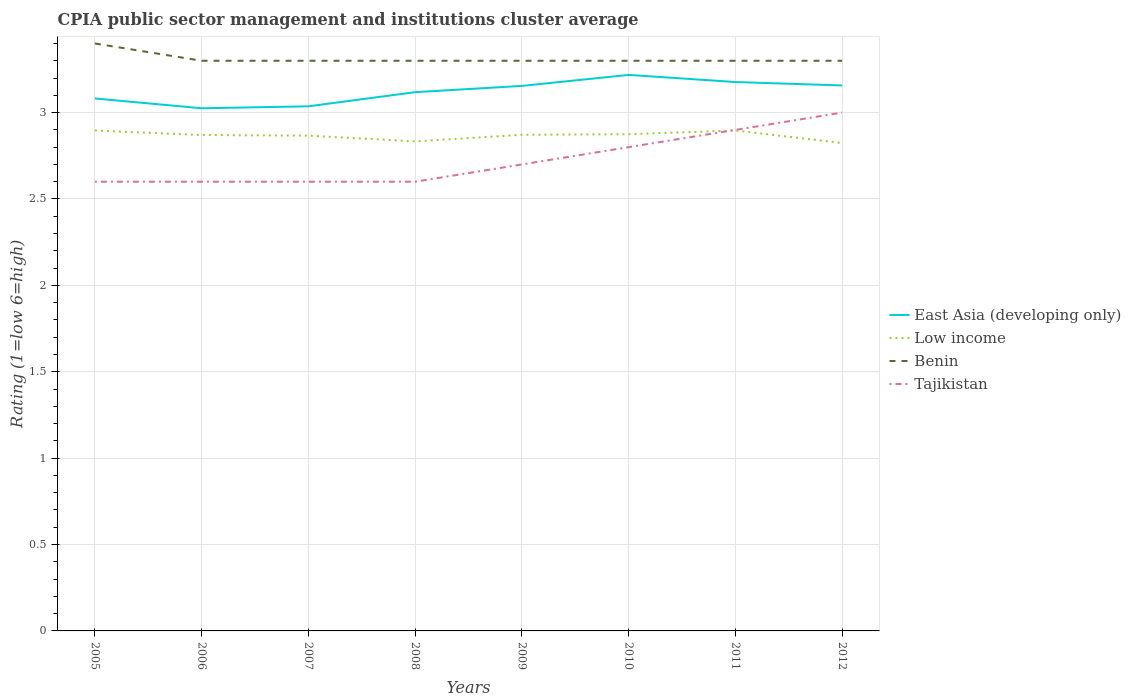Does the line corresponding to Low income intersect with the line corresponding to Benin?
Ensure brevity in your answer.  No. Is the number of lines equal to the number of legend labels?
Your answer should be compact. Yes. Across all years, what is the maximum CPIA rating in East Asia (developing only)?
Offer a very short reply. 3.02. What is the total CPIA rating in Low income in the graph?
Offer a very short reply. 0.06. What is the difference between the highest and the second highest CPIA rating in Tajikistan?
Your response must be concise. 0.4. What is the difference between the highest and the lowest CPIA rating in Benin?
Your answer should be compact. 1. Is the CPIA rating in Low income strictly greater than the CPIA rating in Benin over the years?
Ensure brevity in your answer.  Yes. What is the difference between two consecutive major ticks on the Y-axis?
Your response must be concise. 0.5. Are the values on the major ticks of Y-axis written in scientific E-notation?
Provide a short and direct response. No. Where does the legend appear in the graph?
Your answer should be compact. Center right. How many legend labels are there?
Your response must be concise. 4. What is the title of the graph?
Make the answer very short. CPIA public sector management and institutions cluster average. What is the label or title of the X-axis?
Keep it short and to the point. Years. What is the Rating (1=low 6=high) of East Asia (developing only) in 2005?
Provide a succinct answer. 3.08. What is the Rating (1=low 6=high) in Low income in 2005?
Give a very brief answer. 2.9. What is the Rating (1=low 6=high) of East Asia (developing only) in 2006?
Keep it short and to the point. 3.02. What is the Rating (1=low 6=high) in Low income in 2006?
Keep it short and to the point. 2.87. What is the Rating (1=low 6=high) in Tajikistan in 2006?
Your response must be concise. 2.6. What is the Rating (1=low 6=high) of East Asia (developing only) in 2007?
Your answer should be very brief. 3.04. What is the Rating (1=low 6=high) of Low income in 2007?
Your answer should be very brief. 2.87. What is the Rating (1=low 6=high) in Benin in 2007?
Ensure brevity in your answer.  3.3. What is the Rating (1=low 6=high) in Tajikistan in 2007?
Offer a very short reply. 2.6. What is the Rating (1=low 6=high) of East Asia (developing only) in 2008?
Your response must be concise. 3.12. What is the Rating (1=low 6=high) of Low income in 2008?
Keep it short and to the point. 2.83. What is the Rating (1=low 6=high) in Tajikistan in 2008?
Keep it short and to the point. 2.6. What is the Rating (1=low 6=high) of East Asia (developing only) in 2009?
Your response must be concise. 3.15. What is the Rating (1=low 6=high) in Low income in 2009?
Ensure brevity in your answer.  2.87. What is the Rating (1=low 6=high) in East Asia (developing only) in 2010?
Keep it short and to the point. 3.22. What is the Rating (1=low 6=high) of Low income in 2010?
Your response must be concise. 2.88. What is the Rating (1=low 6=high) of Benin in 2010?
Offer a terse response. 3.3. What is the Rating (1=low 6=high) in Tajikistan in 2010?
Keep it short and to the point. 2.8. What is the Rating (1=low 6=high) in East Asia (developing only) in 2011?
Keep it short and to the point. 3.18. What is the Rating (1=low 6=high) in Low income in 2011?
Keep it short and to the point. 2.9. What is the Rating (1=low 6=high) of Benin in 2011?
Offer a terse response. 3.3. What is the Rating (1=low 6=high) of East Asia (developing only) in 2012?
Provide a short and direct response. 3.16. What is the Rating (1=low 6=high) in Low income in 2012?
Your answer should be compact. 2.82. What is the Rating (1=low 6=high) in Tajikistan in 2012?
Provide a succinct answer. 3. Across all years, what is the maximum Rating (1=low 6=high) of East Asia (developing only)?
Keep it short and to the point. 3.22. Across all years, what is the maximum Rating (1=low 6=high) in Low income?
Your answer should be compact. 2.9. Across all years, what is the maximum Rating (1=low 6=high) in Benin?
Make the answer very short. 3.4. Across all years, what is the maximum Rating (1=low 6=high) of Tajikistan?
Provide a succinct answer. 3. Across all years, what is the minimum Rating (1=low 6=high) of East Asia (developing only)?
Make the answer very short. 3.02. Across all years, what is the minimum Rating (1=low 6=high) of Low income?
Your answer should be very brief. 2.82. Across all years, what is the minimum Rating (1=low 6=high) of Benin?
Offer a terse response. 3.3. Across all years, what is the minimum Rating (1=low 6=high) in Tajikistan?
Your response must be concise. 2.6. What is the total Rating (1=low 6=high) in East Asia (developing only) in the graph?
Your answer should be compact. 24.97. What is the total Rating (1=low 6=high) in Low income in the graph?
Keep it short and to the point. 22.93. What is the total Rating (1=low 6=high) in Benin in the graph?
Offer a terse response. 26.5. What is the total Rating (1=low 6=high) in Tajikistan in the graph?
Provide a succinct answer. 21.8. What is the difference between the Rating (1=low 6=high) of East Asia (developing only) in 2005 and that in 2006?
Offer a terse response. 0.06. What is the difference between the Rating (1=low 6=high) of Low income in 2005 and that in 2006?
Keep it short and to the point. 0.03. What is the difference between the Rating (1=low 6=high) in Tajikistan in 2005 and that in 2006?
Offer a very short reply. 0. What is the difference between the Rating (1=low 6=high) of East Asia (developing only) in 2005 and that in 2007?
Keep it short and to the point. 0.05. What is the difference between the Rating (1=low 6=high) of Low income in 2005 and that in 2007?
Your response must be concise. 0.03. What is the difference between the Rating (1=low 6=high) in East Asia (developing only) in 2005 and that in 2008?
Offer a terse response. -0.04. What is the difference between the Rating (1=low 6=high) in Low income in 2005 and that in 2008?
Offer a very short reply. 0.06. What is the difference between the Rating (1=low 6=high) in Benin in 2005 and that in 2008?
Your answer should be very brief. 0.1. What is the difference between the Rating (1=low 6=high) in East Asia (developing only) in 2005 and that in 2009?
Offer a very short reply. -0.07. What is the difference between the Rating (1=low 6=high) in Low income in 2005 and that in 2009?
Provide a succinct answer. 0.02. What is the difference between the Rating (1=low 6=high) in East Asia (developing only) in 2005 and that in 2010?
Keep it short and to the point. -0.14. What is the difference between the Rating (1=low 6=high) in Low income in 2005 and that in 2010?
Offer a terse response. 0.02. What is the difference between the Rating (1=low 6=high) in Tajikistan in 2005 and that in 2010?
Your answer should be very brief. -0.2. What is the difference between the Rating (1=low 6=high) of East Asia (developing only) in 2005 and that in 2011?
Make the answer very short. -0.1. What is the difference between the Rating (1=low 6=high) of Low income in 2005 and that in 2011?
Your response must be concise. -0. What is the difference between the Rating (1=low 6=high) of Benin in 2005 and that in 2011?
Keep it short and to the point. 0.1. What is the difference between the Rating (1=low 6=high) of Tajikistan in 2005 and that in 2011?
Your answer should be very brief. -0.3. What is the difference between the Rating (1=low 6=high) in East Asia (developing only) in 2005 and that in 2012?
Keep it short and to the point. -0.08. What is the difference between the Rating (1=low 6=high) in Low income in 2005 and that in 2012?
Provide a short and direct response. 0.07. What is the difference between the Rating (1=low 6=high) of East Asia (developing only) in 2006 and that in 2007?
Offer a very short reply. -0.01. What is the difference between the Rating (1=low 6=high) in Low income in 2006 and that in 2007?
Your response must be concise. 0. What is the difference between the Rating (1=low 6=high) of East Asia (developing only) in 2006 and that in 2008?
Give a very brief answer. -0.09. What is the difference between the Rating (1=low 6=high) of Low income in 2006 and that in 2008?
Provide a succinct answer. 0.04. What is the difference between the Rating (1=low 6=high) of Benin in 2006 and that in 2008?
Your answer should be very brief. 0. What is the difference between the Rating (1=low 6=high) of Tajikistan in 2006 and that in 2008?
Provide a succinct answer. 0. What is the difference between the Rating (1=low 6=high) in East Asia (developing only) in 2006 and that in 2009?
Your answer should be compact. -0.13. What is the difference between the Rating (1=low 6=high) of Low income in 2006 and that in 2009?
Your answer should be very brief. -0. What is the difference between the Rating (1=low 6=high) in East Asia (developing only) in 2006 and that in 2010?
Ensure brevity in your answer.  -0.19. What is the difference between the Rating (1=low 6=high) of Low income in 2006 and that in 2010?
Provide a succinct answer. -0. What is the difference between the Rating (1=low 6=high) in East Asia (developing only) in 2006 and that in 2011?
Offer a terse response. -0.15. What is the difference between the Rating (1=low 6=high) of Low income in 2006 and that in 2011?
Your answer should be compact. -0.03. What is the difference between the Rating (1=low 6=high) in East Asia (developing only) in 2006 and that in 2012?
Your answer should be very brief. -0.13. What is the difference between the Rating (1=low 6=high) of Low income in 2006 and that in 2012?
Make the answer very short. 0.05. What is the difference between the Rating (1=low 6=high) of East Asia (developing only) in 2007 and that in 2008?
Give a very brief answer. -0.08. What is the difference between the Rating (1=low 6=high) in Benin in 2007 and that in 2008?
Provide a succinct answer. 0. What is the difference between the Rating (1=low 6=high) of East Asia (developing only) in 2007 and that in 2009?
Provide a short and direct response. -0.12. What is the difference between the Rating (1=low 6=high) of Low income in 2007 and that in 2009?
Keep it short and to the point. -0. What is the difference between the Rating (1=low 6=high) in East Asia (developing only) in 2007 and that in 2010?
Keep it short and to the point. -0.18. What is the difference between the Rating (1=low 6=high) in Low income in 2007 and that in 2010?
Your answer should be compact. -0.01. What is the difference between the Rating (1=low 6=high) in Tajikistan in 2007 and that in 2010?
Your answer should be compact. -0.2. What is the difference between the Rating (1=low 6=high) in East Asia (developing only) in 2007 and that in 2011?
Ensure brevity in your answer.  -0.14. What is the difference between the Rating (1=low 6=high) of Low income in 2007 and that in 2011?
Keep it short and to the point. -0.03. What is the difference between the Rating (1=low 6=high) of Benin in 2007 and that in 2011?
Your answer should be very brief. 0. What is the difference between the Rating (1=low 6=high) in East Asia (developing only) in 2007 and that in 2012?
Give a very brief answer. -0.12. What is the difference between the Rating (1=low 6=high) of Low income in 2007 and that in 2012?
Offer a very short reply. 0.04. What is the difference between the Rating (1=low 6=high) of East Asia (developing only) in 2008 and that in 2009?
Offer a terse response. -0.04. What is the difference between the Rating (1=low 6=high) in Low income in 2008 and that in 2009?
Provide a short and direct response. -0.04. What is the difference between the Rating (1=low 6=high) of Tajikistan in 2008 and that in 2009?
Offer a very short reply. -0.1. What is the difference between the Rating (1=low 6=high) in Low income in 2008 and that in 2010?
Ensure brevity in your answer.  -0.04. What is the difference between the Rating (1=low 6=high) of Tajikistan in 2008 and that in 2010?
Provide a short and direct response. -0.2. What is the difference between the Rating (1=low 6=high) of East Asia (developing only) in 2008 and that in 2011?
Your response must be concise. -0.06. What is the difference between the Rating (1=low 6=high) of Low income in 2008 and that in 2011?
Make the answer very short. -0.06. What is the difference between the Rating (1=low 6=high) in East Asia (developing only) in 2008 and that in 2012?
Your answer should be very brief. -0.04. What is the difference between the Rating (1=low 6=high) of Low income in 2008 and that in 2012?
Ensure brevity in your answer.  0.01. What is the difference between the Rating (1=low 6=high) of Tajikistan in 2008 and that in 2012?
Offer a terse response. -0.4. What is the difference between the Rating (1=low 6=high) in East Asia (developing only) in 2009 and that in 2010?
Ensure brevity in your answer.  -0.06. What is the difference between the Rating (1=low 6=high) of Low income in 2009 and that in 2010?
Provide a succinct answer. -0. What is the difference between the Rating (1=low 6=high) of East Asia (developing only) in 2009 and that in 2011?
Offer a very short reply. -0.02. What is the difference between the Rating (1=low 6=high) in Low income in 2009 and that in 2011?
Offer a very short reply. -0.03. What is the difference between the Rating (1=low 6=high) in Benin in 2009 and that in 2011?
Provide a succinct answer. 0. What is the difference between the Rating (1=low 6=high) of East Asia (developing only) in 2009 and that in 2012?
Your answer should be very brief. -0. What is the difference between the Rating (1=low 6=high) of Low income in 2009 and that in 2012?
Your response must be concise. 0.05. What is the difference between the Rating (1=low 6=high) in East Asia (developing only) in 2010 and that in 2011?
Provide a succinct answer. 0.04. What is the difference between the Rating (1=low 6=high) of Low income in 2010 and that in 2011?
Your response must be concise. -0.02. What is the difference between the Rating (1=low 6=high) in Benin in 2010 and that in 2011?
Ensure brevity in your answer.  0. What is the difference between the Rating (1=low 6=high) in Tajikistan in 2010 and that in 2011?
Make the answer very short. -0.1. What is the difference between the Rating (1=low 6=high) of East Asia (developing only) in 2010 and that in 2012?
Your answer should be very brief. 0.06. What is the difference between the Rating (1=low 6=high) of Low income in 2010 and that in 2012?
Give a very brief answer. 0.05. What is the difference between the Rating (1=low 6=high) of Benin in 2010 and that in 2012?
Ensure brevity in your answer.  0. What is the difference between the Rating (1=low 6=high) in Tajikistan in 2010 and that in 2012?
Keep it short and to the point. -0.2. What is the difference between the Rating (1=low 6=high) in East Asia (developing only) in 2011 and that in 2012?
Offer a very short reply. 0.02. What is the difference between the Rating (1=low 6=high) in Low income in 2011 and that in 2012?
Offer a terse response. 0.07. What is the difference between the Rating (1=low 6=high) of Tajikistan in 2011 and that in 2012?
Provide a succinct answer. -0.1. What is the difference between the Rating (1=low 6=high) of East Asia (developing only) in 2005 and the Rating (1=low 6=high) of Low income in 2006?
Offer a very short reply. 0.21. What is the difference between the Rating (1=low 6=high) in East Asia (developing only) in 2005 and the Rating (1=low 6=high) in Benin in 2006?
Your response must be concise. -0.22. What is the difference between the Rating (1=low 6=high) of East Asia (developing only) in 2005 and the Rating (1=low 6=high) of Tajikistan in 2006?
Offer a very short reply. 0.48. What is the difference between the Rating (1=low 6=high) in Low income in 2005 and the Rating (1=low 6=high) in Benin in 2006?
Keep it short and to the point. -0.4. What is the difference between the Rating (1=low 6=high) of Low income in 2005 and the Rating (1=low 6=high) of Tajikistan in 2006?
Provide a succinct answer. 0.3. What is the difference between the Rating (1=low 6=high) in Benin in 2005 and the Rating (1=low 6=high) in Tajikistan in 2006?
Provide a short and direct response. 0.8. What is the difference between the Rating (1=low 6=high) of East Asia (developing only) in 2005 and the Rating (1=low 6=high) of Low income in 2007?
Your response must be concise. 0.22. What is the difference between the Rating (1=low 6=high) in East Asia (developing only) in 2005 and the Rating (1=low 6=high) in Benin in 2007?
Your response must be concise. -0.22. What is the difference between the Rating (1=low 6=high) of East Asia (developing only) in 2005 and the Rating (1=low 6=high) of Tajikistan in 2007?
Your answer should be very brief. 0.48. What is the difference between the Rating (1=low 6=high) of Low income in 2005 and the Rating (1=low 6=high) of Benin in 2007?
Your response must be concise. -0.4. What is the difference between the Rating (1=low 6=high) of Low income in 2005 and the Rating (1=low 6=high) of Tajikistan in 2007?
Your answer should be compact. 0.3. What is the difference between the Rating (1=low 6=high) in East Asia (developing only) in 2005 and the Rating (1=low 6=high) in Low income in 2008?
Provide a succinct answer. 0.25. What is the difference between the Rating (1=low 6=high) in East Asia (developing only) in 2005 and the Rating (1=low 6=high) in Benin in 2008?
Offer a terse response. -0.22. What is the difference between the Rating (1=low 6=high) in East Asia (developing only) in 2005 and the Rating (1=low 6=high) in Tajikistan in 2008?
Give a very brief answer. 0.48. What is the difference between the Rating (1=low 6=high) of Low income in 2005 and the Rating (1=low 6=high) of Benin in 2008?
Ensure brevity in your answer.  -0.4. What is the difference between the Rating (1=low 6=high) in Low income in 2005 and the Rating (1=low 6=high) in Tajikistan in 2008?
Provide a short and direct response. 0.3. What is the difference between the Rating (1=low 6=high) of East Asia (developing only) in 2005 and the Rating (1=low 6=high) of Low income in 2009?
Provide a short and direct response. 0.21. What is the difference between the Rating (1=low 6=high) in East Asia (developing only) in 2005 and the Rating (1=low 6=high) in Benin in 2009?
Provide a short and direct response. -0.22. What is the difference between the Rating (1=low 6=high) of East Asia (developing only) in 2005 and the Rating (1=low 6=high) of Tajikistan in 2009?
Ensure brevity in your answer.  0.38. What is the difference between the Rating (1=low 6=high) in Low income in 2005 and the Rating (1=low 6=high) in Benin in 2009?
Offer a terse response. -0.4. What is the difference between the Rating (1=low 6=high) of Low income in 2005 and the Rating (1=low 6=high) of Tajikistan in 2009?
Offer a very short reply. 0.2. What is the difference between the Rating (1=low 6=high) of Benin in 2005 and the Rating (1=low 6=high) of Tajikistan in 2009?
Offer a very short reply. 0.7. What is the difference between the Rating (1=low 6=high) of East Asia (developing only) in 2005 and the Rating (1=low 6=high) of Low income in 2010?
Offer a terse response. 0.21. What is the difference between the Rating (1=low 6=high) of East Asia (developing only) in 2005 and the Rating (1=low 6=high) of Benin in 2010?
Give a very brief answer. -0.22. What is the difference between the Rating (1=low 6=high) of East Asia (developing only) in 2005 and the Rating (1=low 6=high) of Tajikistan in 2010?
Make the answer very short. 0.28. What is the difference between the Rating (1=low 6=high) in Low income in 2005 and the Rating (1=low 6=high) in Benin in 2010?
Offer a very short reply. -0.4. What is the difference between the Rating (1=low 6=high) in Low income in 2005 and the Rating (1=low 6=high) in Tajikistan in 2010?
Provide a succinct answer. 0.1. What is the difference between the Rating (1=low 6=high) in East Asia (developing only) in 2005 and the Rating (1=low 6=high) in Low income in 2011?
Provide a succinct answer. 0.19. What is the difference between the Rating (1=low 6=high) of East Asia (developing only) in 2005 and the Rating (1=low 6=high) of Benin in 2011?
Offer a very short reply. -0.22. What is the difference between the Rating (1=low 6=high) in East Asia (developing only) in 2005 and the Rating (1=low 6=high) in Tajikistan in 2011?
Offer a terse response. 0.18. What is the difference between the Rating (1=low 6=high) of Low income in 2005 and the Rating (1=low 6=high) of Benin in 2011?
Make the answer very short. -0.4. What is the difference between the Rating (1=low 6=high) of Low income in 2005 and the Rating (1=low 6=high) of Tajikistan in 2011?
Give a very brief answer. -0. What is the difference between the Rating (1=low 6=high) of East Asia (developing only) in 2005 and the Rating (1=low 6=high) of Low income in 2012?
Your answer should be compact. 0.26. What is the difference between the Rating (1=low 6=high) in East Asia (developing only) in 2005 and the Rating (1=low 6=high) in Benin in 2012?
Offer a very short reply. -0.22. What is the difference between the Rating (1=low 6=high) of East Asia (developing only) in 2005 and the Rating (1=low 6=high) of Tajikistan in 2012?
Keep it short and to the point. 0.08. What is the difference between the Rating (1=low 6=high) in Low income in 2005 and the Rating (1=low 6=high) in Benin in 2012?
Offer a terse response. -0.4. What is the difference between the Rating (1=low 6=high) of Low income in 2005 and the Rating (1=low 6=high) of Tajikistan in 2012?
Keep it short and to the point. -0.1. What is the difference between the Rating (1=low 6=high) in East Asia (developing only) in 2006 and the Rating (1=low 6=high) in Low income in 2007?
Offer a terse response. 0.16. What is the difference between the Rating (1=low 6=high) in East Asia (developing only) in 2006 and the Rating (1=low 6=high) in Benin in 2007?
Your response must be concise. -0.28. What is the difference between the Rating (1=low 6=high) in East Asia (developing only) in 2006 and the Rating (1=low 6=high) in Tajikistan in 2007?
Provide a short and direct response. 0.42. What is the difference between the Rating (1=low 6=high) of Low income in 2006 and the Rating (1=low 6=high) of Benin in 2007?
Your answer should be very brief. -0.43. What is the difference between the Rating (1=low 6=high) in Low income in 2006 and the Rating (1=low 6=high) in Tajikistan in 2007?
Ensure brevity in your answer.  0.27. What is the difference between the Rating (1=low 6=high) in Benin in 2006 and the Rating (1=low 6=high) in Tajikistan in 2007?
Make the answer very short. 0.7. What is the difference between the Rating (1=low 6=high) in East Asia (developing only) in 2006 and the Rating (1=low 6=high) in Low income in 2008?
Ensure brevity in your answer.  0.19. What is the difference between the Rating (1=low 6=high) of East Asia (developing only) in 2006 and the Rating (1=low 6=high) of Benin in 2008?
Your answer should be compact. -0.28. What is the difference between the Rating (1=low 6=high) of East Asia (developing only) in 2006 and the Rating (1=low 6=high) of Tajikistan in 2008?
Give a very brief answer. 0.42. What is the difference between the Rating (1=low 6=high) in Low income in 2006 and the Rating (1=low 6=high) in Benin in 2008?
Provide a succinct answer. -0.43. What is the difference between the Rating (1=low 6=high) of Low income in 2006 and the Rating (1=low 6=high) of Tajikistan in 2008?
Ensure brevity in your answer.  0.27. What is the difference between the Rating (1=low 6=high) of East Asia (developing only) in 2006 and the Rating (1=low 6=high) of Low income in 2009?
Provide a short and direct response. 0.15. What is the difference between the Rating (1=low 6=high) in East Asia (developing only) in 2006 and the Rating (1=low 6=high) in Benin in 2009?
Offer a terse response. -0.28. What is the difference between the Rating (1=low 6=high) of East Asia (developing only) in 2006 and the Rating (1=low 6=high) of Tajikistan in 2009?
Your answer should be compact. 0.33. What is the difference between the Rating (1=low 6=high) of Low income in 2006 and the Rating (1=low 6=high) of Benin in 2009?
Provide a succinct answer. -0.43. What is the difference between the Rating (1=low 6=high) of Low income in 2006 and the Rating (1=low 6=high) of Tajikistan in 2009?
Offer a terse response. 0.17. What is the difference between the Rating (1=low 6=high) of Benin in 2006 and the Rating (1=low 6=high) of Tajikistan in 2009?
Provide a short and direct response. 0.6. What is the difference between the Rating (1=low 6=high) in East Asia (developing only) in 2006 and the Rating (1=low 6=high) in Benin in 2010?
Offer a very short reply. -0.28. What is the difference between the Rating (1=low 6=high) in East Asia (developing only) in 2006 and the Rating (1=low 6=high) in Tajikistan in 2010?
Offer a terse response. 0.23. What is the difference between the Rating (1=low 6=high) of Low income in 2006 and the Rating (1=low 6=high) of Benin in 2010?
Your answer should be very brief. -0.43. What is the difference between the Rating (1=low 6=high) of Low income in 2006 and the Rating (1=low 6=high) of Tajikistan in 2010?
Your answer should be very brief. 0.07. What is the difference between the Rating (1=low 6=high) of East Asia (developing only) in 2006 and the Rating (1=low 6=high) of Low income in 2011?
Make the answer very short. 0.13. What is the difference between the Rating (1=low 6=high) in East Asia (developing only) in 2006 and the Rating (1=low 6=high) in Benin in 2011?
Offer a terse response. -0.28. What is the difference between the Rating (1=low 6=high) of East Asia (developing only) in 2006 and the Rating (1=low 6=high) of Tajikistan in 2011?
Give a very brief answer. 0.12. What is the difference between the Rating (1=low 6=high) in Low income in 2006 and the Rating (1=low 6=high) in Benin in 2011?
Make the answer very short. -0.43. What is the difference between the Rating (1=low 6=high) in Low income in 2006 and the Rating (1=low 6=high) in Tajikistan in 2011?
Provide a short and direct response. -0.03. What is the difference between the Rating (1=low 6=high) of Benin in 2006 and the Rating (1=low 6=high) of Tajikistan in 2011?
Ensure brevity in your answer.  0.4. What is the difference between the Rating (1=low 6=high) in East Asia (developing only) in 2006 and the Rating (1=low 6=high) in Low income in 2012?
Provide a succinct answer. 0.2. What is the difference between the Rating (1=low 6=high) in East Asia (developing only) in 2006 and the Rating (1=low 6=high) in Benin in 2012?
Ensure brevity in your answer.  -0.28. What is the difference between the Rating (1=low 6=high) in East Asia (developing only) in 2006 and the Rating (1=low 6=high) in Tajikistan in 2012?
Your response must be concise. 0.03. What is the difference between the Rating (1=low 6=high) in Low income in 2006 and the Rating (1=low 6=high) in Benin in 2012?
Offer a very short reply. -0.43. What is the difference between the Rating (1=low 6=high) of Low income in 2006 and the Rating (1=low 6=high) of Tajikistan in 2012?
Offer a very short reply. -0.13. What is the difference between the Rating (1=low 6=high) of East Asia (developing only) in 2007 and the Rating (1=low 6=high) of Low income in 2008?
Ensure brevity in your answer.  0.2. What is the difference between the Rating (1=low 6=high) in East Asia (developing only) in 2007 and the Rating (1=low 6=high) in Benin in 2008?
Give a very brief answer. -0.26. What is the difference between the Rating (1=low 6=high) of East Asia (developing only) in 2007 and the Rating (1=low 6=high) of Tajikistan in 2008?
Offer a terse response. 0.44. What is the difference between the Rating (1=low 6=high) of Low income in 2007 and the Rating (1=low 6=high) of Benin in 2008?
Offer a very short reply. -0.43. What is the difference between the Rating (1=low 6=high) in Low income in 2007 and the Rating (1=low 6=high) in Tajikistan in 2008?
Make the answer very short. 0.27. What is the difference between the Rating (1=low 6=high) of Benin in 2007 and the Rating (1=low 6=high) of Tajikistan in 2008?
Offer a terse response. 0.7. What is the difference between the Rating (1=low 6=high) of East Asia (developing only) in 2007 and the Rating (1=low 6=high) of Low income in 2009?
Offer a very short reply. 0.16. What is the difference between the Rating (1=low 6=high) of East Asia (developing only) in 2007 and the Rating (1=low 6=high) of Benin in 2009?
Your answer should be compact. -0.26. What is the difference between the Rating (1=low 6=high) in East Asia (developing only) in 2007 and the Rating (1=low 6=high) in Tajikistan in 2009?
Keep it short and to the point. 0.34. What is the difference between the Rating (1=low 6=high) in Low income in 2007 and the Rating (1=low 6=high) in Benin in 2009?
Your answer should be compact. -0.43. What is the difference between the Rating (1=low 6=high) of Low income in 2007 and the Rating (1=low 6=high) of Tajikistan in 2009?
Provide a succinct answer. 0.17. What is the difference between the Rating (1=low 6=high) of Benin in 2007 and the Rating (1=low 6=high) of Tajikistan in 2009?
Make the answer very short. 0.6. What is the difference between the Rating (1=low 6=high) in East Asia (developing only) in 2007 and the Rating (1=low 6=high) in Low income in 2010?
Your answer should be compact. 0.16. What is the difference between the Rating (1=low 6=high) of East Asia (developing only) in 2007 and the Rating (1=low 6=high) of Benin in 2010?
Keep it short and to the point. -0.26. What is the difference between the Rating (1=low 6=high) of East Asia (developing only) in 2007 and the Rating (1=low 6=high) of Tajikistan in 2010?
Your answer should be compact. 0.24. What is the difference between the Rating (1=low 6=high) of Low income in 2007 and the Rating (1=low 6=high) of Benin in 2010?
Your response must be concise. -0.43. What is the difference between the Rating (1=low 6=high) of Low income in 2007 and the Rating (1=low 6=high) of Tajikistan in 2010?
Make the answer very short. 0.07. What is the difference between the Rating (1=low 6=high) in East Asia (developing only) in 2007 and the Rating (1=low 6=high) in Low income in 2011?
Give a very brief answer. 0.14. What is the difference between the Rating (1=low 6=high) of East Asia (developing only) in 2007 and the Rating (1=low 6=high) of Benin in 2011?
Offer a very short reply. -0.26. What is the difference between the Rating (1=low 6=high) in East Asia (developing only) in 2007 and the Rating (1=low 6=high) in Tajikistan in 2011?
Ensure brevity in your answer.  0.14. What is the difference between the Rating (1=low 6=high) of Low income in 2007 and the Rating (1=low 6=high) of Benin in 2011?
Your answer should be compact. -0.43. What is the difference between the Rating (1=low 6=high) of Low income in 2007 and the Rating (1=low 6=high) of Tajikistan in 2011?
Offer a terse response. -0.03. What is the difference between the Rating (1=low 6=high) of East Asia (developing only) in 2007 and the Rating (1=low 6=high) of Low income in 2012?
Ensure brevity in your answer.  0.21. What is the difference between the Rating (1=low 6=high) of East Asia (developing only) in 2007 and the Rating (1=low 6=high) of Benin in 2012?
Offer a very short reply. -0.26. What is the difference between the Rating (1=low 6=high) in East Asia (developing only) in 2007 and the Rating (1=low 6=high) in Tajikistan in 2012?
Your answer should be very brief. 0.04. What is the difference between the Rating (1=low 6=high) in Low income in 2007 and the Rating (1=low 6=high) in Benin in 2012?
Your answer should be very brief. -0.43. What is the difference between the Rating (1=low 6=high) in Low income in 2007 and the Rating (1=low 6=high) in Tajikistan in 2012?
Make the answer very short. -0.13. What is the difference between the Rating (1=low 6=high) in Benin in 2007 and the Rating (1=low 6=high) in Tajikistan in 2012?
Offer a terse response. 0.3. What is the difference between the Rating (1=low 6=high) of East Asia (developing only) in 2008 and the Rating (1=low 6=high) of Low income in 2009?
Make the answer very short. 0.25. What is the difference between the Rating (1=low 6=high) of East Asia (developing only) in 2008 and the Rating (1=low 6=high) of Benin in 2009?
Give a very brief answer. -0.18. What is the difference between the Rating (1=low 6=high) of East Asia (developing only) in 2008 and the Rating (1=low 6=high) of Tajikistan in 2009?
Offer a terse response. 0.42. What is the difference between the Rating (1=low 6=high) in Low income in 2008 and the Rating (1=low 6=high) in Benin in 2009?
Your answer should be very brief. -0.47. What is the difference between the Rating (1=low 6=high) in Low income in 2008 and the Rating (1=low 6=high) in Tajikistan in 2009?
Your answer should be very brief. 0.13. What is the difference between the Rating (1=low 6=high) of East Asia (developing only) in 2008 and the Rating (1=low 6=high) of Low income in 2010?
Offer a terse response. 0.24. What is the difference between the Rating (1=low 6=high) in East Asia (developing only) in 2008 and the Rating (1=low 6=high) in Benin in 2010?
Provide a succinct answer. -0.18. What is the difference between the Rating (1=low 6=high) in East Asia (developing only) in 2008 and the Rating (1=low 6=high) in Tajikistan in 2010?
Provide a succinct answer. 0.32. What is the difference between the Rating (1=low 6=high) of Low income in 2008 and the Rating (1=low 6=high) of Benin in 2010?
Make the answer very short. -0.47. What is the difference between the Rating (1=low 6=high) in Low income in 2008 and the Rating (1=low 6=high) in Tajikistan in 2010?
Keep it short and to the point. 0.03. What is the difference between the Rating (1=low 6=high) of Benin in 2008 and the Rating (1=low 6=high) of Tajikistan in 2010?
Provide a succinct answer. 0.5. What is the difference between the Rating (1=low 6=high) in East Asia (developing only) in 2008 and the Rating (1=low 6=high) in Low income in 2011?
Keep it short and to the point. 0.22. What is the difference between the Rating (1=low 6=high) of East Asia (developing only) in 2008 and the Rating (1=low 6=high) of Benin in 2011?
Your answer should be compact. -0.18. What is the difference between the Rating (1=low 6=high) of East Asia (developing only) in 2008 and the Rating (1=low 6=high) of Tajikistan in 2011?
Offer a very short reply. 0.22. What is the difference between the Rating (1=low 6=high) in Low income in 2008 and the Rating (1=low 6=high) in Benin in 2011?
Provide a succinct answer. -0.47. What is the difference between the Rating (1=low 6=high) in Low income in 2008 and the Rating (1=low 6=high) in Tajikistan in 2011?
Your response must be concise. -0.07. What is the difference between the Rating (1=low 6=high) in Benin in 2008 and the Rating (1=low 6=high) in Tajikistan in 2011?
Make the answer very short. 0.4. What is the difference between the Rating (1=low 6=high) in East Asia (developing only) in 2008 and the Rating (1=low 6=high) in Low income in 2012?
Ensure brevity in your answer.  0.29. What is the difference between the Rating (1=low 6=high) of East Asia (developing only) in 2008 and the Rating (1=low 6=high) of Benin in 2012?
Offer a very short reply. -0.18. What is the difference between the Rating (1=low 6=high) of East Asia (developing only) in 2008 and the Rating (1=low 6=high) of Tajikistan in 2012?
Your answer should be compact. 0.12. What is the difference between the Rating (1=low 6=high) in Low income in 2008 and the Rating (1=low 6=high) in Benin in 2012?
Your answer should be compact. -0.47. What is the difference between the Rating (1=low 6=high) in Low income in 2008 and the Rating (1=low 6=high) in Tajikistan in 2012?
Make the answer very short. -0.17. What is the difference between the Rating (1=low 6=high) in East Asia (developing only) in 2009 and the Rating (1=low 6=high) in Low income in 2010?
Keep it short and to the point. 0.28. What is the difference between the Rating (1=low 6=high) of East Asia (developing only) in 2009 and the Rating (1=low 6=high) of Benin in 2010?
Ensure brevity in your answer.  -0.15. What is the difference between the Rating (1=low 6=high) of East Asia (developing only) in 2009 and the Rating (1=low 6=high) of Tajikistan in 2010?
Your answer should be very brief. 0.35. What is the difference between the Rating (1=low 6=high) in Low income in 2009 and the Rating (1=low 6=high) in Benin in 2010?
Make the answer very short. -0.43. What is the difference between the Rating (1=low 6=high) in Low income in 2009 and the Rating (1=low 6=high) in Tajikistan in 2010?
Offer a very short reply. 0.07. What is the difference between the Rating (1=low 6=high) of East Asia (developing only) in 2009 and the Rating (1=low 6=high) of Low income in 2011?
Offer a very short reply. 0.26. What is the difference between the Rating (1=low 6=high) of East Asia (developing only) in 2009 and the Rating (1=low 6=high) of Benin in 2011?
Your answer should be very brief. -0.15. What is the difference between the Rating (1=low 6=high) in East Asia (developing only) in 2009 and the Rating (1=low 6=high) in Tajikistan in 2011?
Your response must be concise. 0.25. What is the difference between the Rating (1=low 6=high) of Low income in 2009 and the Rating (1=low 6=high) of Benin in 2011?
Provide a short and direct response. -0.43. What is the difference between the Rating (1=low 6=high) in Low income in 2009 and the Rating (1=low 6=high) in Tajikistan in 2011?
Offer a very short reply. -0.03. What is the difference between the Rating (1=low 6=high) of East Asia (developing only) in 2009 and the Rating (1=low 6=high) of Low income in 2012?
Make the answer very short. 0.33. What is the difference between the Rating (1=low 6=high) of East Asia (developing only) in 2009 and the Rating (1=low 6=high) of Benin in 2012?
Provide a succinct answer. -0.15. What is the difference between the Rating (1=low 6=high) in East Asia (developing only) in 2009 and the Rating (1=low 6=high) in Tajikistan in 2012?
Keep it short and to the point. 0.15. What is the difference between the Rating (1=low 6=high) of Low income in 2009 and the Rating (1=low 6=high) of Benin in 2012?
Provide a succinct answer. -0.43. What is the difference between the Rating (1=low 6=high) of Low income in 2009 and the Rating (1=low 6=high) of Tajikistan in 2012?
Ensure brevity in your answer.  -0.13. What is the difference between the Rating (1=low 6=high) of Benin in 2009 and the Rating (1=low 6=high) of Tajikistan in 2012?
Your answer should be compact. 0.3. What is the difference between the Rating (1=low 6=high) in East Asia (developing only) in 2010 and the Rating (1=low 6=high) in Low income in 2011?
Your response must be concise. 0.32. What is the difference between the Rating (1=low 6=high) in East Asia (developing only) in 2010 and the Rating (1=low 6=high) in Benin in 2011?
Ensure brevity in your answer.  -0.08. What is the difference between the Rating (1=low 6=high) in East Asia (developing only) in 2010 and the Rating (1=low 6=high) in Tajikistan in 2011?
Provide a short and direct response. 0.32. What is the difference between the Rating (1=low 6=high) in Low income in 2010 and the Rating (1=low 6=high) in Benin in 2011?
Provide a short and direct response. -0.42. What is the difference between the Rating (1=low 6=high) in Low income in 2010 and the Rating (1=low 6=high) in Tajikistan in 2011?
Provide a succinct answer. -0.03. What is the difference between the Rating (1=low 6=high) in Benin in 2010 and the Rating (1=low 6=high) in Tajikistan in 2011?
Offer a terse response. 0.4. What is the difference between the Rating (1=low 6=high) of East Asia (developing only) in 2010 and the Rating (1=low 6=high) of Low income in 2012?
Your response must be concise. 0.39. What is the difference between the Rating (1=low 6=high) of East Asia (developing only) in 2010 and the Rating (1=low 6=high) of Benin in 2012?
Your answer should be very brief. -0.08. What is the difference between the Rating (1=low 6=high) in East Asia (developing only) in 2010 and the Rating (1=low 6=high) in Tajikistan in 2012?
Keep it short and to the point. 0.22. What is the difference between the Rating (1=low 6=high) in Low income in 2010 and the Rating (1=low 6=high) in Benin in 2012?
Provide a succinct answer. -0.42. What is the difference between the Rating (1=low 6=high) of Low income in 2010 and the Rating (1=low 6=high) of Tajikistan in 2012?
Your response must be concise. -0.12. What is the difference between the Rating (1=low 6=high) of Benin in 2010 and the Rating (1=low 6=high) of Tajikistan in 2012?
Give a very brief answer. 0.3. What is the difference between the Rating (1=low 6=high) of East Asia (developing only) in 2011 and the Rating (1=low 6=high) of Low income in 2012?
Your answer should be very brief. 0.35. What is the difference between the Rating (1=low 6=high) of East Asia (developing only) in 2011 and the Rating (1=low 6=high) of Benin in 2012?
Offer a very short reply. -0.12. What is the difference between the Rating (1=low 6=high) of East Asia (developing only) in 2011 and the Rating (1=low 6=high) of Tajikistan in 2012?
Provide a succinct answer. 0.18. What is the difference between the Rating (1=low 6=high) of Low income in 2011 and the Rating (1=low 6=high) of Benin in 2012?
Your answer should be very brief. -0.4. What is the difference between the Rating (1=low 6=high) in Low income in 2011 and the Rating (1=low 6=high) in Tajikistan in 2012?
Your response must be concise. -0.1. What is the average Rating (1=low 6=high) of East Asia (developing only) per year?
Your response must be concise. 3.12. What is the average Rating (1=low 6=high) of Low income per year?
Your answer should be very brief. 2.87. What is the average Rating (1=low 6=high) in Benin per year?
Your response must be concise. 3.31. What is the average Rating (1=low 6=high) of Tajikistan per year?
Offer a terse response. 2.73. In the year 2005, what is the difference between the Rating (1=low 6=high) in East Asia (developing only) and Rating (1=low 6=high) in Low income?
Give a very brief answer. 0.19. In the year 2005, what is the difference between the Rating (1=low 6=high) of East Asia (developing only) and Rating (1=low 6=high) of Benin?
Ensure brevity in your answer.  -0.32. In the year 2005, what is the difference between the Rating (1=low 6=high) of East Asia (developing only) and Rating (1=low 6=high) of Tajikistan?
Make the answer very short. 0.48. In the year 2005, what is the difference between the Rating (1=low 6=high) of Low income and Rating (1=low 6=high) of Benin?
Give a very brief answer. -0.5. In the year 2005, what is the difference between the Rating (1=low 6=high) of Low income and Rating (1=low 6=high) of Tajikistan?
Offer a terse response. 0.3. In the year 2006, what is the difference between the Rating (1=low 6=high) in East Asia (developing only) and Rating (1=low 6=high) in Low income?
Make the answer very short. 0.15. In the year 2006, what is the difference between the Rating (1=low 6=high) in East Asia (developing only) and Rating (1=low 6=high) in Benin?
Your answer should be compact. -0.28. In the year 2006, what is the difference between the Rating (1=low 6=high) in East Asia (developing only) and Rating (1=low 6=high) in Tajikistan?
Your answer should be very brief. 0.42. In the year 2006, what is the difference between the Rating (1=low 6=high) of Low income and Rating (1=low 6=high) of Benin?
Make the answer very short. -0.43. In the year 2006, what is the difference between the Rating (1=low 6=high) in Low income and Rating (1=low 6=high) in Tajikistan?
Your response must be concise. 0.27. In the year 2006, what is the difference between the Rating (1=low 6=high) in Benin and Rating (1=low 6=high) in Tajikistan?
Provide a succinct answer. 0.7. In the year 2007, what is the difference between the Rating (1=low 6=high) of East Asia (developing only) and Rating (1=low 6=high) of Low income?
Offer a terse response. 0.17. In the year 2007, what is the difference between the Rating (1=low 6=high) in East Asia (developing only) and Rating (1=low 6=high) in Benin?
Ensure brevity in your answer.  -0.26. In the year 2007, what is the difference between the Rating (1=low 6=high) in East Asia (developing only) and Rating (1=low 6=high) in Tajikistan?
Your response must be concise. 0.44. In the year 2007, what is the difference between the Rating (1=low 6=high) in Low income and Rating (1=low 6=high) in Benin?
Provide a succinct answer. -0.43. In the year 2007, what is the difference between the Rating (1=low 6=high) of Low income and Rating (1=low 6=high) of Tajikistan?
Your response must be concise. 0.27. In the year 2007, what is the difference between the Rating (1=low 6=high) of Benin and Rating (1=low 6=high) of Tajikistan?
Your response must be concise. 0.7. In the year 2008, what is the difference between the Rating (1=low 6=high) in East Asia (developing only) and Rating (1=low 6=high) in Low income?
Keep it short and to the point. 0.28. In the year 2008, what is the difference between the Rating (1=low 6=high) of East Asia (developing only) and Rating (1=low 6=high) of Benin?
Give a very brief answer. -0.18. In the year 2008, what is the difference between the Rating (1=low 6=high) in East Asia (developing only) and Rating (1=low 6=high) in Tajikistan?
Provide a short and direct response. 0.52. In the year 2008, what is the difference between the Rating (1=low 6=high) of Low income and Rating (1=low 6=high) of Benin?
Provide a succinct answer. -0.47. In the year 2008, what is the difference between the Rating (1=low 6=high) of Low income and Rating (1=low 6=high) of Tajikistan?
Give a very brief answer. 0.23. In the year 2008, what is the difference between the Rating (1=low 6=high) of Benin and Rating (1=low 6=high) of Tajikistan?
Keep it short and to the point. 0.7. In the year 2009, what is the difference between the Rating (1=low 6=high) in East Asia (developing only) and Rating (1=low 6=high) in Low income?
Your response must be concise. 0.28. In the year 2009, what is the difference between the Rating (1=low 6=high) of East Asia (developing only) and Rating (1=low 6=high) of Benin?
Give a very brief answer. -0.15. In the year 2009, what is the difference between the Rating (1=low 6=high) of East Asia (developing only) and Rating (1=low 6=high) of Tajikistan?
Your response must be concise. 0.45. In the year 2009, what is the difference between the Rating (1=low 6=high) of Low income and Rating (1=low 6=high) of Benin?
Your answer should be compact. -0.43. In the year 2009, what is the difference between the Rating (1=low 6=high) of Low income and Rating (1=low 6=high) of Tajikistan?
Offer a terse response. 0.17. In the year 2009, what is the difference between the Rating (1=low 6=high) in Benin and Rating (1=low 6=high) in Tajikistan?
Keep it short and to the point. 0.6. In the year 2010, what is the difference between the Rating (1=low 6=high) in East Asia (developing only) and Rating (1=low 6=high) in Low income?
Offer a terse response. 0.34. In the year 2010, what is the difference between the Rating (1=low 6=high) of East Asia (developing only) and Rating (1=low 6=high) of Benin?
Provide a succinct answer. -0.08. In the year 2010, what is the difference between the Rating (1=low 6=high) of East Asia (developing only) and Rating (1=low 6=high) of Tajikistan?
Provide a succinct answer. 0.42. In the year 2010, what is the difference between the Rating (1=low 6=high) of Low income and Rating (1=low 6=high) of Benin?
Give a very brief answer. -0.42. In the year 2010, what is the difference between the Rating (1=low 6=high) of Low income and Rating (1=low 6=high) of Tajikistan?
Give a very brief answer. 0.07. In the year 2010, what is the difference between the Rating (1=low 6=high) in Benin and Rating (1=low 6=high) in Tajikistan?
Ensure brevity in your answer.  0.5. In the year 2011, what is the difference between the Rating (1=low 6=high) of East Asia (developing only) and Rating (1=low 6=high) of Low income?
Offer a very short reply. 0.28. In the year 2011, what is the difference between the Rating (1=low 6=high) in East Asia (developing only) and Rating (1=low 6=high) in Benin?
Your answer should be compact. -0.12. In the year 2011, what is the difference between the Rating (1=low 6=high) in East Asia (developing only) and Rating (1=low 6=high) in Tajikistan?
Offer a very short reply. 0.28. In the year 2011, what is the difference between the Rating (1=low 6=high) in Low income and Rating (1=low 6=high) in Benin?
Provide a short and direct response. -0.4. In the year 2011, what is the difference between the Rating (1=low 6=high) in Low income and Rating (1=low 6=high) in Tajikistan?
Provide a succinct answer. -0. In the year 2012, what is the difference between the Rating (1=low 6=high) of East Asia (developing only) and Rating (1=low 6=high) of Low income?
Offer a terse response. 0.33. In the year 2012, what is the difference between the Rating (1=low 6=high) of East Asia (developing only) and Rating (1=low 6=high) of Benin?
Make the answer very short. -0.14. In the year 2012, what is the difference between the Rating (1=low 6=high) in East Asia (developing only) and Rating (1=low 6=high) in Tajikistan?
Keep it short and to the point. 0.16. In the year 2012, what is the difference between the Rating (1=low 6=high) of Low income and Rating (1=low 6=high) of Benin?
Give a very brief answer. -0.48. In the year 2012, what is the difference between the Rating (1=low 6=high) of Low income and Rating (1=low 6=high) of Tajikistan?
Provide a succinct answer. -0.18. What is the ratio of the Rating (1=low 6=high) in East Asia (developing only) in 2005 to that in 2006?
Your answer should be very brief. 1.02. What is the ratio of the Rating (1=low 6=high) in Benin in 2005 to that in 2006?
Provide a succinct answer. 1.03. What is the ratio of the Rating (1=low 6=high) of Low income in 2005 to that in 2007?
Your response must be concise. 1.01. What is the ratio of the Rating (1=low 6=high) of Benin in 2005 to that in 2007?
Provide a succinct answer. 1.03. What is the ratio of the Rating (1=low 6=high) of Tajikistan in 2005 to that in 2007?
Provide a succinct answer. 1. What is the ratio of the Rating (1=low 6=high) of East Asia (developing only) in 2005 to that in 2008?
Provide a succinct answer. 0.99. What is the ratio of the Rating (1=low 6=high) in Low income in 2005 to that in 2008?
Provide a short and direct response. 1.02. What is the ratio of the Rating (1=low 6=high) of Benin in 2005 to that in 2008?
Ensure brevity in your answer.  1.03. What is the ratio of the Rating (1=low 6=high) of East Asia (developing only) in 2005 to that in 2009?
Offer a terse response. 0.98. What is the ratio of the Rating (1=low 6=high) of Low income in 2005 to that in 2009?
Your response must be concise. 1.01. What is the ratio of the Rating (1=low 6=high) in Benin in 2005 to that in 2009?
Your answer should be compact. 1.03. What is the ratio of the Rating (1=low 6=high) of Tajikistan in 2005 to that in 2009?
Offer a very short reply. 0.96. What is the ratio of the Rating (1=low 6=high) in East Asia (developing only) in 2005 to that in 2010?
Offer a very short reply. 0.96. What is the ratio of the Rating (1=low 6=high) of Low income in 2005 to that in 2010?
Your answer should be compact. 1.01. What is the ratio of the Rating (1=low 6=high) of Benin in 2005 to that in 2010?
Offer a terse response. 1.03. What is the ratio of the Rating (1=low 6=high) of Tajikistan in 2005 to that in 2010?
Your response must be concise. 0.93. What is the ratio of the Rating (1=low 6=high) in East Asia (developing only) in 2005 to that in 2011?
Ensure brevity in your answer.  0.97. What is the ratio of the Rating (1=low 6=high) of Low income in 2005 to that in 2011?
Provide a short and direct response. 1. What is the ratio of the Rating (1=low 6=high) of Benin in 2005 to that in 2011?
Your answer should be compact. 1.03. What is the ratio of the Rating (1=low 6=high) in Tajikistan in 2005 to that in 2011?
Give a very brief answer. 0.9. What is the ratio of the Rating (1=low 6=high) of East Asia (developing only) in 2005 to that in 2012?
Ensure brevity in your answer.  0.98. What is the ratio of the Rating (1=low 6=high) of Low income in 2005 to that in 2012?
Provide a short and direct response. 1.03. What is the ratio of the Rating (1=low 6=high) of Benin in 2005 to that in 2012?
Offer a terse response. 1.03. What is the ratio of the Rating (1=low 6=high) in Tajikistan in 2005 to that in 2012?
Offer a very short reply. 0.87. What is the ratio of the Rating (1=low 6=high) of East Asia (developing only) in 2006 to that in 2007?
Give a very brief answer. 1. What is the ratio of the Rating (1=low 6=high) of Low income in 2006 to that in 2007?
Keep it short and to the point. 1. What is the ratio of the Rating (1=low 6=high) of Benin in 2006 to that in 2007?
Your answer should be very brief. 1. What is the ratio of the Rating (1=low 6=high) in Tajikistan in 2006 to that in 2007?
Keep it short and to the point. 1. What is the ratio of the Rating (1=low 6=high) in East Asia (developing only) in 2006 to that in 2008?
Your answer should be compact. 0.97. What is the ratio of the Rating (1=low 6=high) in Low income in 2006 to that in 2008?
Make the answer very short. 1.01. What is the ratio of the Rating (1=low 6=high) in East Asia (developing only) in 2006 to that in 2009?
Your response must be concise. 0.96. What is the ratio of the Rating (1=low 6=high) of Low income in 2006 to that in 2009?
Ensure brevity in your answer.  1. What is the ratio of the Rating (1=low 6=high) of Benin in 2006 to that in 2009?
Provide a short and direct response. 1. What is the ratio of the Rating (1=low 6=high) in Tajikistan in 2006 to that in 2009?
Offer a terse response. 0.96. What is the ratio of the Rating (1=low 6=high) in Low income in 2006 to that in 2010?
Provide a short and direct response. 1. What is the ratio of the Rating (1=low 6=high) in Benin in 2006 to that in 2010?
Offer a terse response. 1. What is the ratio of the Rating (1=low 6=high) in East Asia (developing only) in 2006 to that in 2011?
Your answer should be very brief. 0.95. What is the ratio of the Rating (1=low 6=high) in Tajikistan in 2006 to that in 2011?
Give a very brief answer. 0.9. What is the ratio of the Rating (1=low 6=high) of East Asia (developing only) in 2006 to that in 2012?
Your answer should be very brief. 0.96. What is the ratio of the Rating (1=low 6=high) in Low income in 2006 to that in 2012?
Offer a very short reply. 1.02. What is the ratio of the Rating (1=low 6=high) of Benin in 2006 to that in 2012?
Ensure brevity in your answer.  1. What is the ratio of the Rating (1=low 6=high) of Tajikistan in 2006 to that in 2012?
Your response must be concise. 0.87. What is the ratio of the Rating (1=low 6=high) in East Asia (developing only) in 2007 to that in 2008?
Keep it short and to the point. 0.97. What is the ratio of the Rating (1=low 6=high) in Low income in 2007 to that in 2008?
Provide a short and direct response. 1.01. What is the ratio of the Rating (1=low 6=high) of East Asia (developing only) in 2007 to that in 2009?
Your response must be concise. 0.96. What is the ratio of the Rating (1=low 6=high) of Benin in 2007 to that in 2009?
Your response must be concise. 1. What is the ratio of the Rating (1=low 6=high) of Tajikistan in 2007 to that in 2009?
Your response must be concise. 0.96. What is the ratio of the Rating (1=low 6=high) in East Asia (developing only) in 2007 to that in 2010?
Give a very brief answer. 0.94. What is the ratio of the Rating (1=low 6=high) of Low income in 2007 to that in 2010?
Provide a succinct answer. 1. What is the ratio of the Rating (1=low 6=high) in Benin in 2007 to that in 2010?
Your answer should be very brief. 1. What is the ratio of the Rating (1=low 6=high) in East Asia (developing only) in 2007 to that in 2011?
Provide a short and direct response. 0.96. What is the ratio of the Rating (1=low 6=high) of Tajikistan in 2007 to that in 2011?
Offer a terse response. 0.9. What is the ratio of the Rating (1=low 6=high) in East Asia (developing only) in 2007 to that in 2012?
Your answer should be very brief. 0.96. What is the ratio of the Rating (1=low 6=high) of Low income in 2007 to that in 2012?
Make the answer very short. 1.02. What is the ratio of the Rating (1=low 6=high) of Benin in 2007 to that in 2012?
Keep it short and to the point. 1. What is the ratio of the Rating (1=low 6=high) in Tajikistan in 2007 to that in 2012?
Your response must be concise. 0.87. What is the ratio of the Rating (1=low 6=high) in East Asia (developing only) in 2008 to that in 2009?
Your answer should be very brief. 0.99. What is the ratio of the Rating (1=low 6=high) of Low income in 2008 to that in 2009?
Keep it short and to the point. 0.99. What is the ratio of the Rating (1=low 6=high) of Tajikistan in 2008 to that in 2009?
Offer a very short reply. 0.96. What is the ratio of the Rating (1=low 6=high) of East Asia (developing only) in 2008 to that in 2010?
Keep it short and to the point. 0.97. What is the ratio of the Rating (1=low 6=high) in Low income in 2008 to that in 2010?
Provide a succinct answer. 0.99. What is the ratio of the Rating (1=low 6=high) in Tajikistan in 2008 to that in 2010?
Keep it short and to the point. 0.93. What is the ratio of the Rating (1=low 6=high) of East Asia (developing only) in 2008 to that in 2011?
Make the answer very short. 0.98. What is the ratio of the Rating (1=low 6=high) of Low income in 2008 to that in 2011?
Make the answer very short. 0.98. What is the ratio of the Rating (1=low 6=high) in Benin in 2008 to that in 2011?
Ensure brevity in your answer.  1. What is the ratio of the Rating (1=low 6=high) in Tajikistan in 2008 to that in 2011?
Give a very brief answer. 0.9. What is the ratio of the Rating (1=low 6=high) in Tajikistan in 2008 to that in 2012?
Make the answer very short. 0.87. What is the ratio of the Rating (1=low 6=high) of East Asia (developing only) in 2009 to that in 2010?
Your answer should be very brief. 0.98. What is the ratio of the Rating (1=low 6=high) in Low income in 2009 to that in 2010?
Your answer should be very brief. 1. What is the ratio of the Rating (1=low 6=high) in Benin in 2009 to that in 2010?
Offer a terse response. 1. What is the ratio of the Rating (1=low 6=high) in Tajikistan in 2009 to that in 2010?
Your response must be concise. 0.96. What is the ratio of the Rating (1=low 6=high) in Tajikistan in 2009 to that in 2011?
Provide a short and direct response. 0.93. What is the ratio of the Rating (1=low 6=high) in Low income in 2009 to that in 2012?
Provide a succinct answer. 1.02. What is the ratio of the Rating (1=low 6=high) of East Asia (developing only) in 2010 to that in 2011?
Keep it short and to the point. 1.01. What is the ratio of the Rating (1=low 6=high) in Low income in 2010 to that in 2011?
Offer a terse response. 0.99. What is the ratio of the Rating (1=low 6=high) in Benin in 2010 to that in 2011?
Give a very brief answer. 1. What is the ratio of the Rating (1=low 6=high) in Tajikistan in 2010 to that in 2011?
Provide a short and direct response. 0.97. What is the ratio of the Rating (1=low 6=high) of East Asia (developing only) in 2010 to that in 2012?
Provide a succinct answer. 1.02. What is the ratio of the Rating (1=low 6=high) in Benin in 2010 to that in 2012?
Provide a succinct answer. 1. What is the ratio of the Rating (1=low 6=high) of Low income in 2011 to that in 2012?
Your response must be concise. 1.03. What is the ratio of the Rating (1=low 6=high) in Benin in 2011 to that in 2012?
Make the answer very short. 1. What is the ratio of the Rating (1=low 6=high) in Tajikistan in 2011 to that in 2012?
Your answer should be very brief. 0.97. What is the difference between the highest and the second highest Rating (1=low 6=high) in East Asia (developing only)?
Offer a terse response. 0.04. What is the difference between the highest and the second highest Rating (1=low 6=high) in Low income?
Your answer should be very brief. 0. What is the difference between the highest and the second highest Rating (1=low 6=high) in Benin?
Your response must be concise. 0.1. What is the difference between the highest and the lowest Rating (1=low 6=high) of East Asia (developing only)?
Offer a very short reply. 0.19. What is the difference between the highest and the lowest Rating (1=low 6=high) in Low income?
Provide a short and direct response. 0.07. What is the difference between the highest and the lowest Rating (1=low 6=high) of Benin?
Your response must be concise. 0.1. 